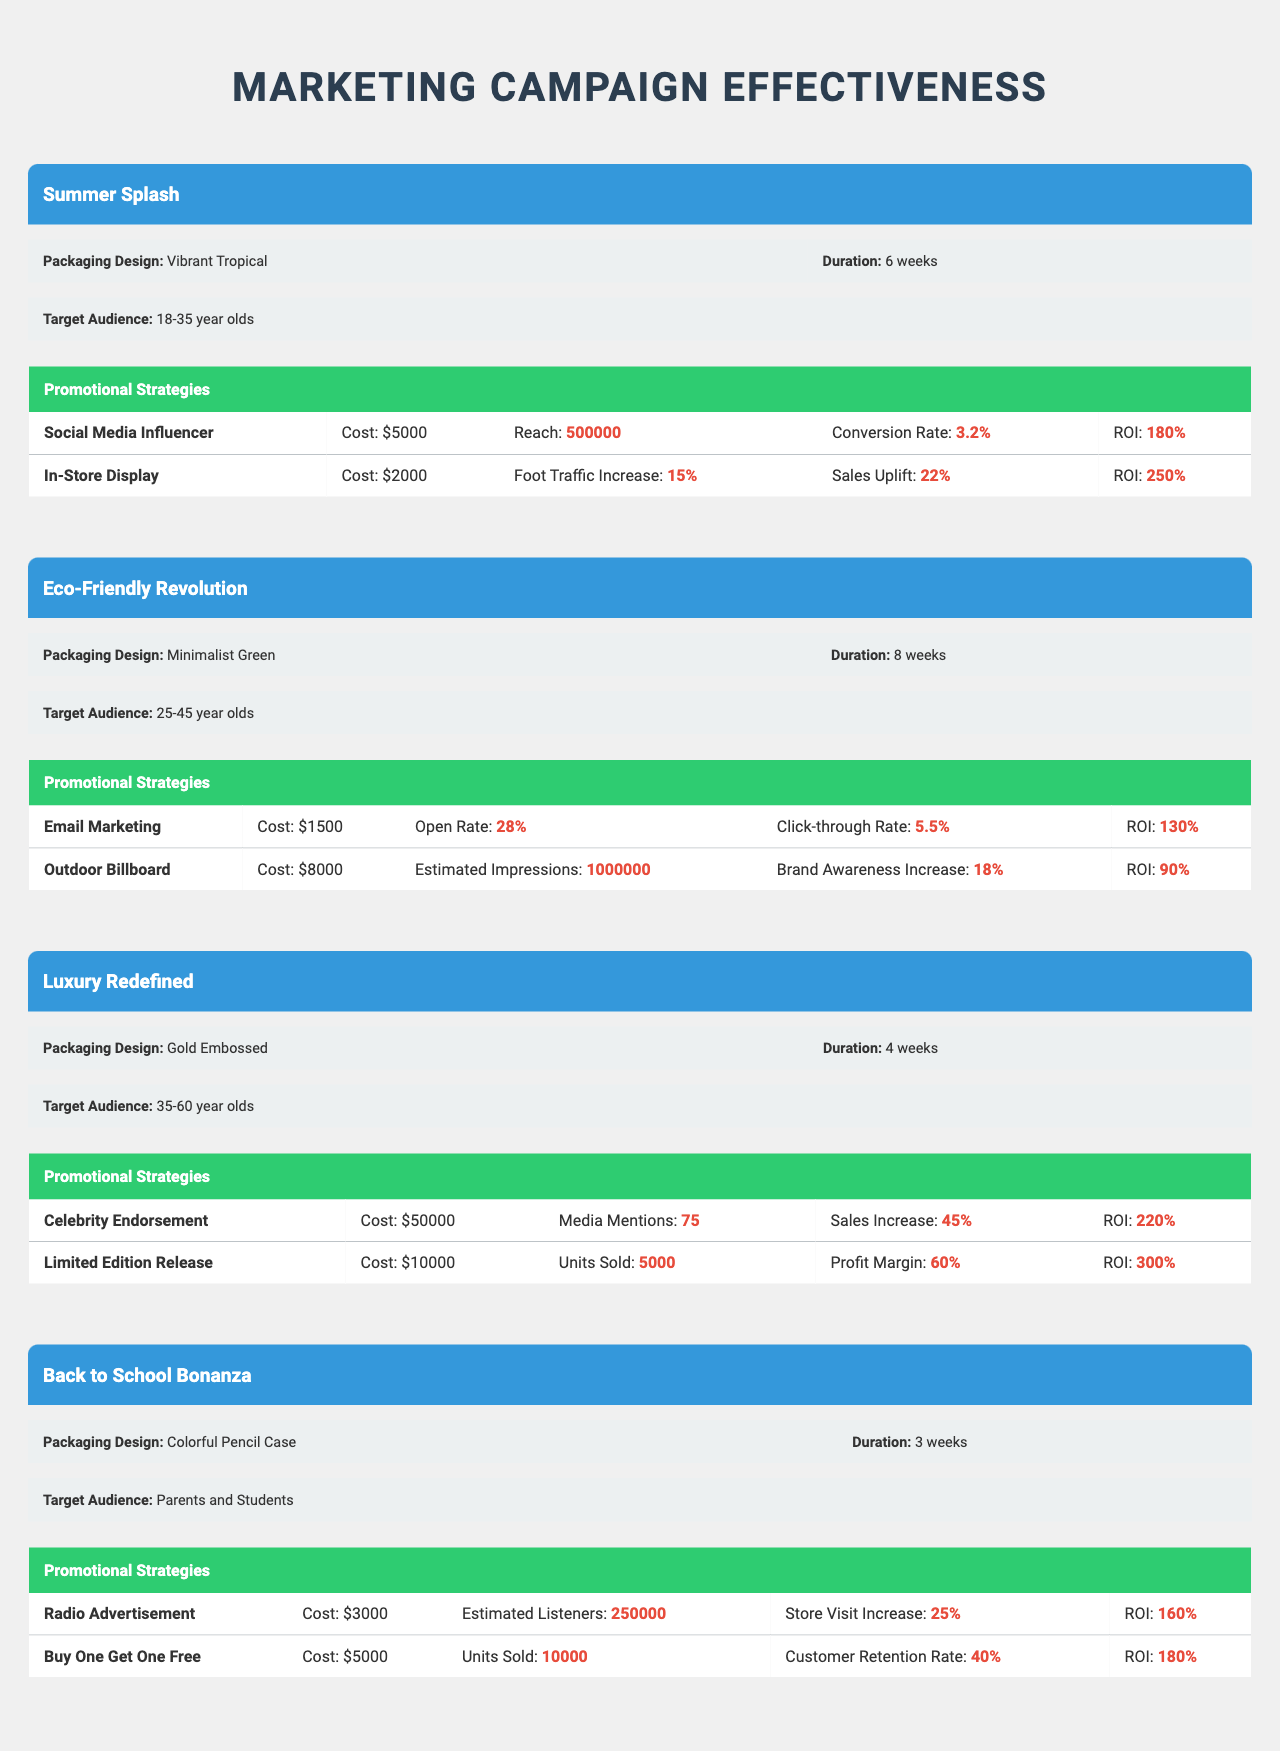What is the ROI for the "Back to School Bonanza" campaign using the "Buy One Get One Free" strategy? The ROI for the "Back to School Bonanza" campaign under the "Buy One Get One Free" strategy is listed as "180%" in the table.
Answer: 180% Which campaign had the highest sales uplift from an in-store display? The "Summer Splash" campaign had a sales uplift of "22%" from the in-store display strategy, which is the highest among the campaigns shown.
Answer: 22% Did the "Eco-Friendly Revolution" campaign utilize any influencer marketing? No, the "Eco-Friendly Revolution" campaign did not use any influencer marketing, as it focused on "Email Marketing" and "Outdoor Billboard" strategies.
Answer: No What was the average cost of promotional strategies for the "Luxury Redefined" campaign? The total cost of the promotional strategies for the "Luxury Redefined" campaign is $50,000 + $10,000 = $60,000, and since there are 2 strategies, the average is 60,000 / 2 = $30,000.
Answer: $30,000 Which packaging design had the shortest campaign duration? The "Colorful Pencil Case" packaging under the "Back to School Bonanza" campaign had the shortest duration of "3 weeks".
Answer: 3 weeks Which campaign showed the highest return on investment? The "Luxury Redefined" campaign's "Limited Edition Release" strategy had the highest ROI at "300%".
Answer: 300% How much did the "Celebrity Endorsement" strategy cost in the "Luxury Redefined" campaign? The cost for the "Celebrity Endorsement" strategy in the "Luxury Redefined" campaign is $50,000, as indicated in the table.
Answer: $50,000 Is the foot traffic increase for the "In-Store Display" in the "Summer Splash" campaign greater than 15%? Yes, the foot traffic increase for the "In-Store Display" in the "Summer Splash" campaign is reported as "15%", which is equal to but not greater than 15%. However, it cannot exceed this value.
Answer: No What was the estimated number of listeners from the "Radio Advertisement" in the "Back to School Bonanza"? The estimated number of listeners from the "Radio Advertisement" in the "Back to School Bonanza" campaign was 250,000, based on the information provided in the table.
Answer: 250,000 Which campaign targeted the youngest audience, and what is their age range? The "Summer Splash" campaign targeted the youngest audience, consisting of "18-35 year olds".
Answer: 18-35 years old 